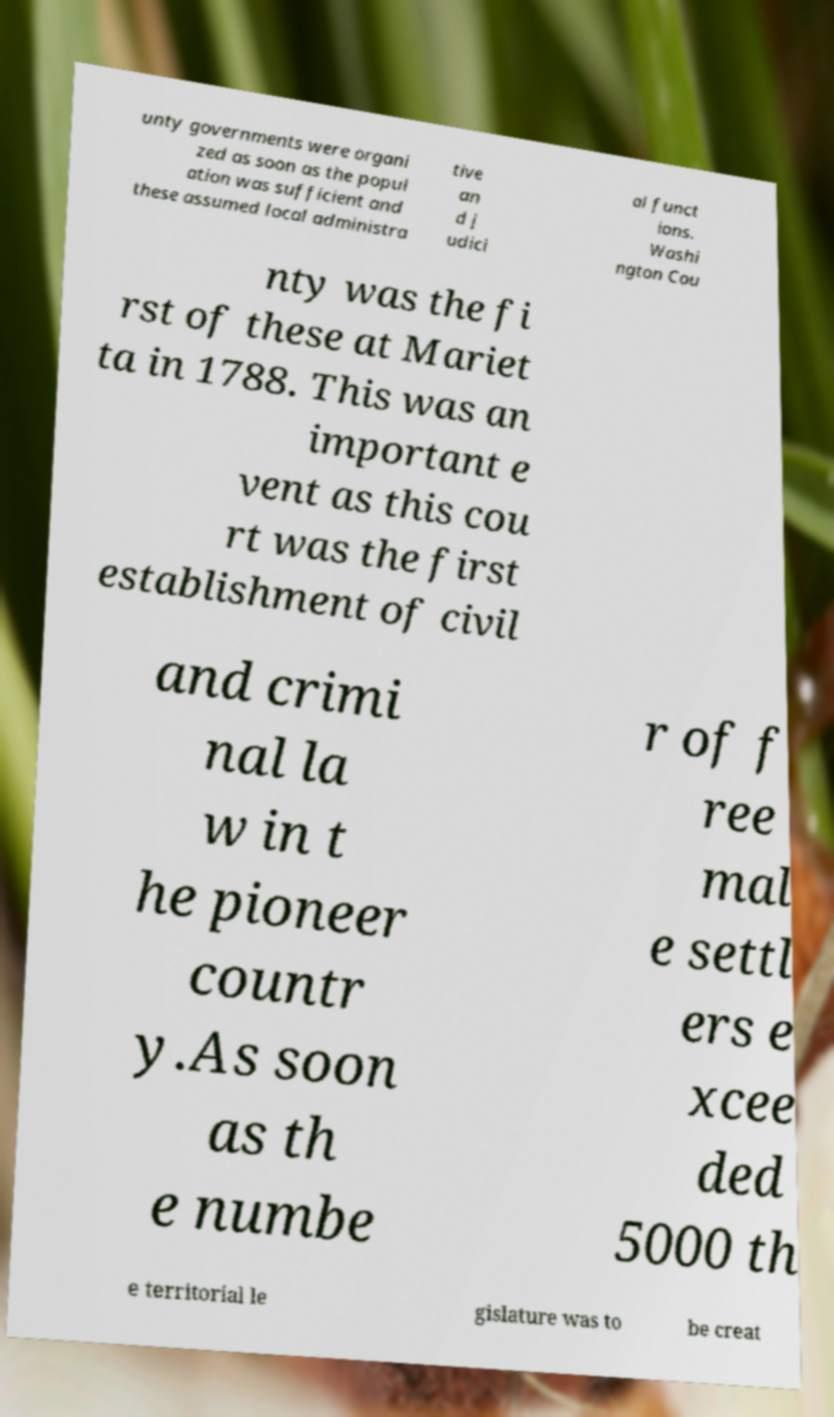For documentation purposes, I need the text within this image transcribed. Could you provide that? unty governments were organi zed as soon as the popul ation was sufficient and these assumed local administra tive an d j udici al funct ions. Washi ngton Cou nty was the fi rst of these at Mariet ta in 1788. This was an important e vent as this cou rt was the first establishment of civil and crimi nal la w in t he pioneer countr y.As soon as th e numbe r of f ree mal e settl ers e xcee ded 5000 th e territorial le gislature was to be creat 